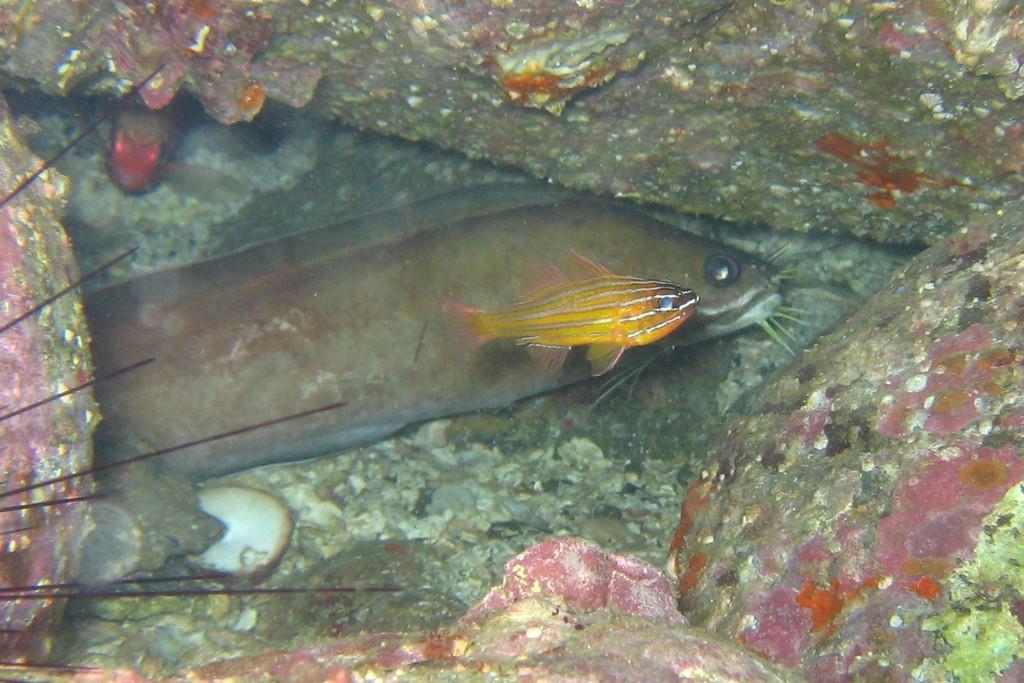In one or two sentences, can you explain what this image depicts? This image consist of two fishes. One is small, another one is big. 